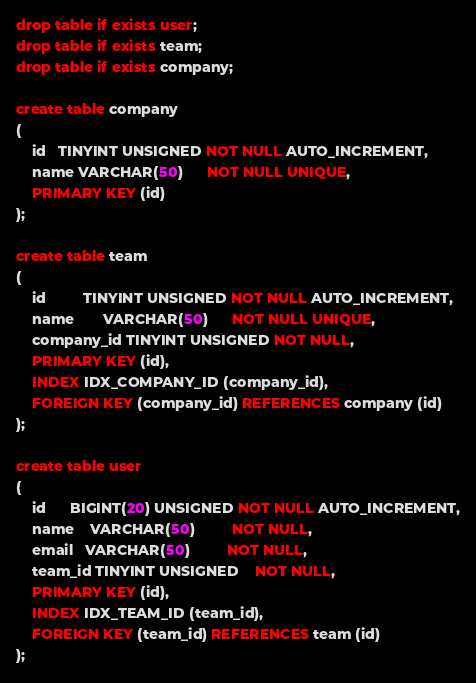<code> <loc_0><loc_0><loc_500><loc_500><_SQL_>drop table if exists user;
drop table if exists team;
drop table if exists company;

create table company
(
    id   TINYINT UNSIGNED NOT NULL AUTO_INCREMENT,
    name VARCHAR(50)      NOT NULL UNIQUE,
    PRIMARY KEY (id)
);

create table team
(
    id         TINYINT UNSIGNED NOT NULL AUTO_INCREMENT,
    name       VARCHAR(50)      NOT NULL UNIQUE,
    company_id TINYINT UNSIGNED NOT NULL,
    PRIMARY KEY (id),
    INDEX IDX_COMPANY_ID (company_id),
    FOREIGN KEY (company_id) REFERENCES company (id)
);

create table user
(
    id      BIGINT(20) UNSIGNED NOT NULL AUTO_INCREMENT,
    name    VARCHAR(50)         NOT NULL,
    email   VARCHAR(50)         NOT NULL,
    team_id TINYINT UNSIGNED    NOT NULL,
    PRIMARY KEY (id),
    INDEX IDX_TEAM_ID (team_id),
    FOREIGN KEY (team_id) REFERENCES team (id)
);</code> 